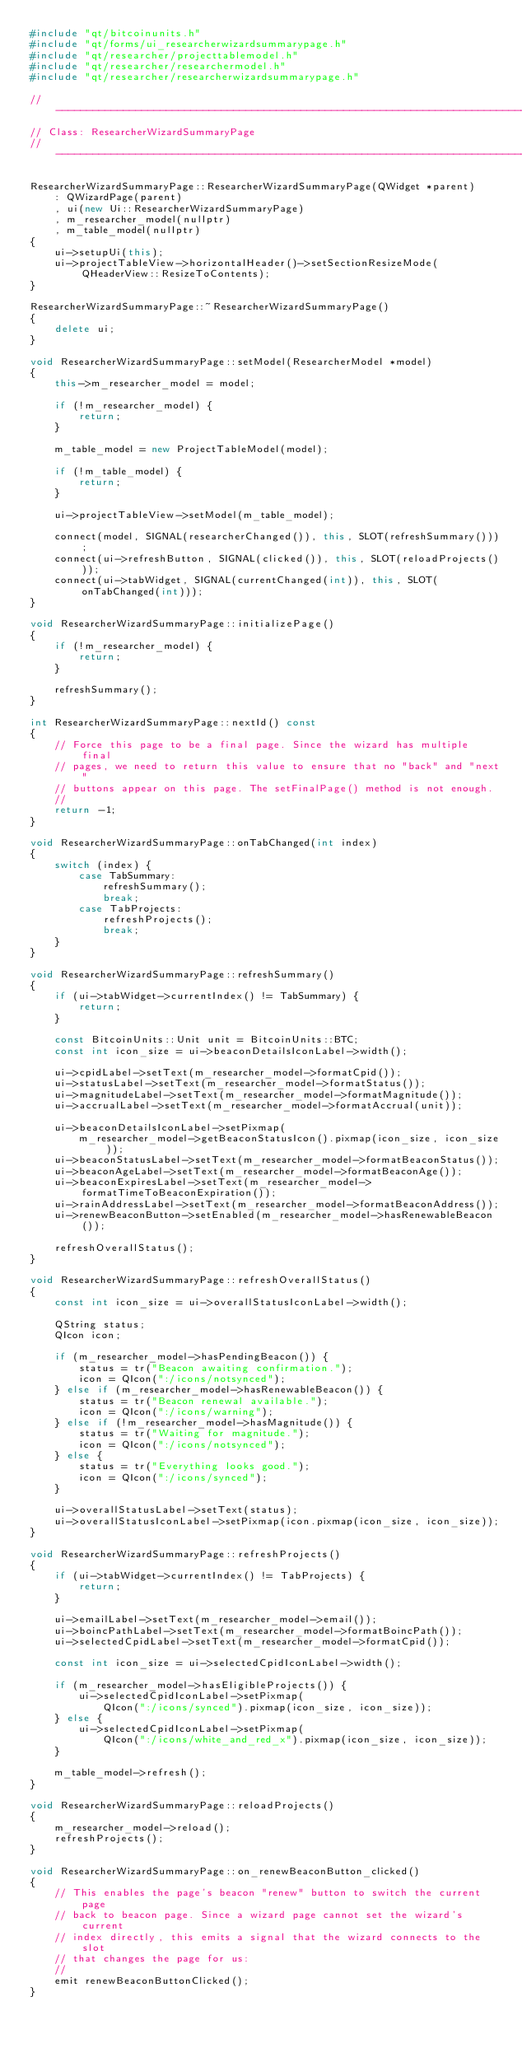<code> <loc_0><loc_0><loc_500><loc_500><_C++_>#include "qt/bitcoinunits.h"
#include "qt/forms/ui_researcherwizardsummarypage.h"
#include "qt/researcher/projecttablemodel.h"
#include "qt/researcher/researchermodel.h"
#include "qt/researcher/researcherwizardsummarypage.h"

// -----------------------------------------------------------------------------
// Class: ResearcherWizardSummaryPage
// -----------------------------------------------------------------------------

ResearcherWizardSummaryPage::ResearcherWizardSummaryPage(QWidget *parent)
    : QWizardPage(parent)
    , ui(new Ui::ResearcherWizardSummaryPage)
    , m_researcher_model(nullptr)
    , m_table_model(nullptr)
{
    ui->setupUi(this);
    ui->projectTableView->horizontalHeader()->setSectionResizeMode(QHeaderView::ResizeToContents);
}

ResearcherWizardSummaryPage::~ResearcherWizardSummaryPage()
{
    delete ui;
}

void ResearcherWizardSummaryPage::setModel(ResearcherModel *model)
{
    this->m_researcher_model = model;

    if (!m_researcher_model) {
        return;
    }

    m_table_model = new ProjectTableModel(model);

    if (!m_table_model) {
        return;
    }

    ui->projectTableView->setModel(m_table_model);

    connect(model, SIGNAL(researcherChanged()), this, SLOT(refreshSummary()));
    connect(ui->refreshButton, SIGNAL(clicked()), this, SLOT(reloadProjects()));
    connect(ui->tabWidget, SIGNAL(currentChanged(int)), this, SLOT(onTabChanged(int)));
}

void ResearcherWizardSummaryPage::initializePage()
{
    if (!m_researcher_model) {
        return;
    }

    refreshSummary();
}

int ResearcherWizardSummaryPage::nextId() const
{
    // Force this page to be a final page. Since the wizard has multiple final
    // pages, we need to return this value to ensure that no "back" and "next"
    // buttons appear on this page. The setFinalPage() method is not enough.
    //
    return -1;
}

void ResearcherWizardSummaryPage::onTabChanged(int index)
{
    switch (index) {
        case TabSummary:
            refreshSummary();
            break;
        case TabProjects:
            refreshProjects();
            break;
    }
}

void ResearcherWizardSummaryPage::refreshSummary()
{
    if (ui->tabWidget->currentIndex() != TabSummary) {
        return;
    }

    const BitcoinUnits::Unit unit = BitcoinUnits::BTC;
    const int icon_size = ui->beaconDetailsIconLabel->width();

    ui->cpidLabel->setText(m_researcher_model->formatCpid());
    ui->statusLabel->setText(m_researcher_model->formatStatus());
    ui->magnitudeLabel->setText(m_researcher_model->formatMagnitude());
    ui->accrualLabel->setText(m_researcher_model->formatAccrual(unit));

    ui->beaconDetailsIconLabel->setPixmap(
        m_researcher_model->getBeaconStatusIcon().pixmap(icon_size, icon_size));
    ui->beaconStatusLabel->setText(m_researcher_model->formatBeaconStatus());
    ui->beaconAgeLabel->setText(m_researcher_model->formatBeaconAge());
    ui->beaconExpiresLabel->setText(m_researcher_model->formatTimeToBeaconExpiration());
    ui->rainAddressLabel->setText(m_researcher_model->formatBeaconAddress());
    ui->renewBeaconButton->setEnabled(m_researcher_model->hasRenewableBeacon());

    refreshOverallStatus();
}

void ResearcherWizardSummaryPage::refreshOverallStatus()
{
    const int icon_size = ui->overallStatusIconLabel->width();

    QString status;
    QIcon icon;

    if (m_researcher_model->hasPendingBeacon()) {
        status = tr("Beacon awaiting confirmation.");
        icon = QIcon(":/icons/notsynced");
    } else if (m_researcher_model->hasRenewableBeacon()) {
        status = tr("Beacon renewal available.");
        icon = QIcon(":/icons/warning");
    } else if (!m_researcher_model->hasMagnitude()) {
        status = tr("Waiting for magnitude.");
        icon = QIcon(":/icons/notsynced");
    } else {
        status = tr("Everything looks good.");
        icon = QIcon(":/icons/synced");
    }

    ui->overallStatusLabel->setText(status);
    ui->overallStatusIconLabel->setPixmap(icon.pixmap(icon_size, icon_size));
}

void ResearcherWizardSummaryPage::refreshProjects()
{
    if (ui->tabWidget->currentIndex() != TabProjects) {
        return;
    }

    ui->emailLabel->setText(m_researcher_model->email());
    ui->boincPathLabel->setText(m_researcher_model->formatBoincPath());
    ui->selectedCpidLabel->setText(m_researcher_model->formatCpid());

    const int icon_size = ui->selectedCpidIconLabel->width();

    if (m_researcher_model->hasEligibleProjects()) {
        ui->selectedCpidIconLabel->setPixmap(
            QIcon(":/icons/synced").pixmap(icon_size, icon_size));
    } else {
        ui->selectedCpidIconLabel->setPixmap(
            QIcon(":/icons/white_and_red_x").pixmap(icon_size, icon_size));
    }

    m_table_model->refresh();
}

void ResearcherWizardSummaryPage::reloadProjects()
{
    m_researcher_model->reload();
    refreshProjects();
}

void ResearcherWizardSummaryPage::on_renewBeaconButton_clicked()
{
    // This enables the page's beacon "renew" button to switch the current page
    // back to beacon page. Since a wizard page cannot set the wizard's current
    // index directly, this emits a signal that the wizard connects to the slot
    // that changes the page for us:
    //
    emit renewBeaconButtonClicked();
}
</code> 